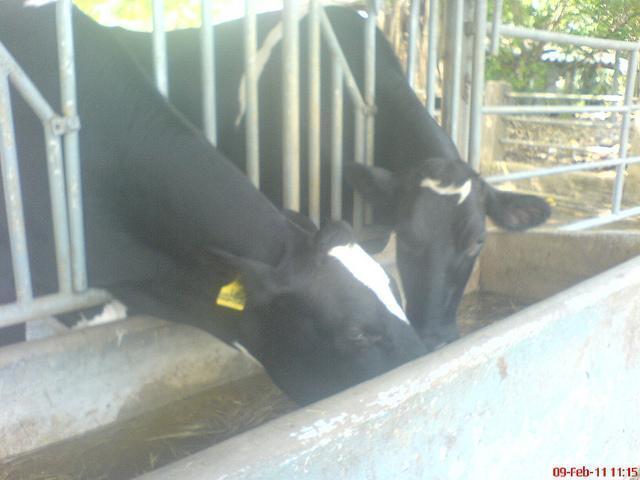How many cows are in the picture?
Give a very brief answer. 2. How many people are wearing glasses?
Give a very brief answer. 0. 